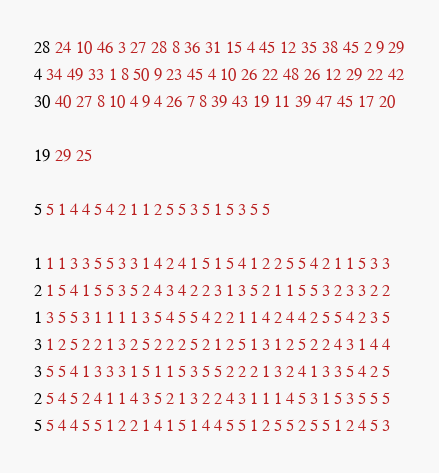<code> <loc_0><loc_0><loc_500><loc_500><_Matlab_>28 24 10 46 3 27 28 8 36 31 15 4 45 12 35 38 45 2 9 29
4 34 49 33 1 8 50 9 23 45 4 10 26 22 48 26 12 29 22 42
30 40 27 8 10 4 9 4 26 7 8 39 43 19 11 39 47 45 17 20

19 29 25

5 5 1 4 4 5 4 2 1 1 2 5 5 3 5 1 5 3 5 5

1 1 1 3 3 5 5 3 3 1 4 2 4 1 5 1 5 4 1 2 2 5 5 4 2 1 1 5 3 3
2 1 5 4 1 5 5 3 5 2 4 3 4 2 2 3 1 3 5 2 1 1 5 5 3 2 3 3 2 2
1 3 5 5 3 1 1 1 1 3 5 4 5 5 4 2 2 1 1 4 2 4 4 2 5 5 4 2 3 5
3 1 2 5 2 2 1 3 2 5 2 2 2 5 2 1 2 5 1 3 1 2 5 2 2 4 3 1 4 4
3 5 5 4 1 3 3 3 1 5 1 1 5 3 5 5 2 2 2 1 3 2 4 1 3 3 5 4 2 5
2 5 4 5 2 4 1 1 4 3 5 2 1 3 2 2 4 3 1 1 1 4 5 3 1 5 3 5 5 5
5 5 4 4 5 5 1 2 2 1 4 1 5 1 4 4 5 5 1 2 5 5 2 5 5 1 2 4 5 3</code> 